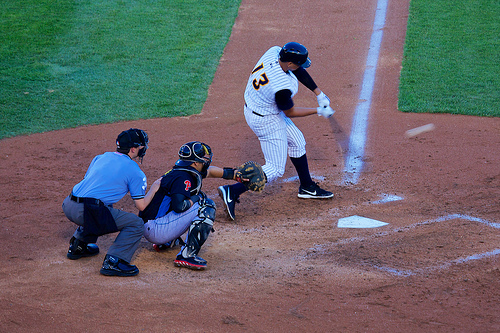Who wears the shirt? The umpire, identifiable by his distinct blue shirt, wears it to stand out on the field. 